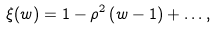<formula> <loc_0><loc_0><loc_500><loc_500>\xi ( w ) = 1 - \rho ^ { 2 } \left ( w - 1 \right ) + \dots ,</formula> 